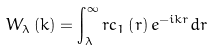Convert formula to latex. <formula><loc_0><loc_0><loc_500><loc_500>W _ { \lambda } \left ( k \right ) = \int _ { \lambda } ^ { \infty } r { c } _ { 1 } \left ( r \right ) e ^ { - i k r } d r</formula> 